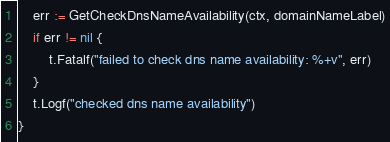<code> <loc_0><loc_0><loc_500><loc_500><_Go_>
	err := GetCheckDnsNameAvailability(ctx, domainNameLabel)
	if err != nil {
		t.Fatalf("failed to check dns name availability: %+v", err)
	}
	t.Logf("checked dns name availability")
}
</code> 